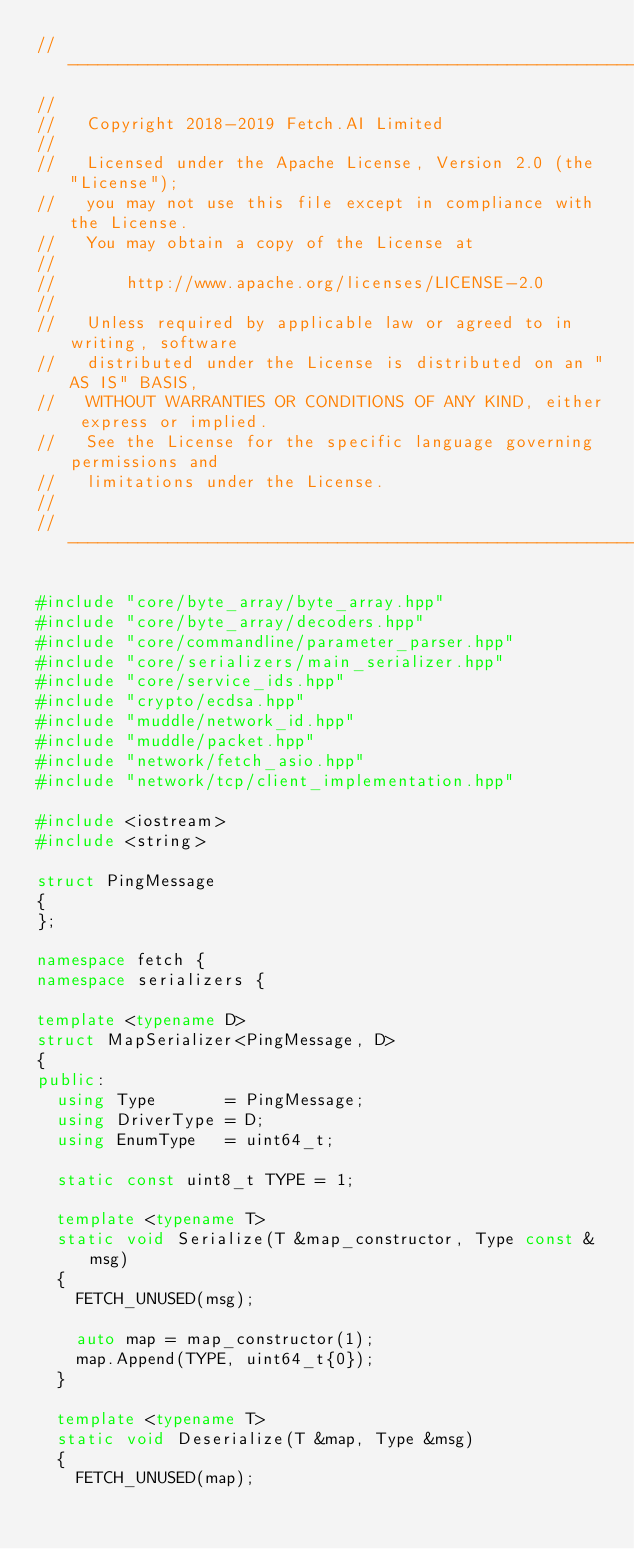Convert code to text. <code><loc_0><loc_0><loc_500><loc_500><_C++_>//------------------------------------------------------------------------------
//
//   Copyright 2018-2019 Fetch.AI Limited
//
//   Licensed under the Apache License, Version 2.0 (the "License");
//   you may not use this file except in compliance with the License.
//   You may obtain a copy of the License at
//
//       http://www.apache.org/licenses/LICENSE-2.0
//
//   Unless required by applicable law or agreed to in writing, software
//   distributed under the License is distributed on an "AS IS" BASIS,
//   WITHOUT WARRANTIES OR CONDITIONS OF ANY KIND, either express or implied.
//   See the License for the specific language governing permissions and
//   limitations under the License.
//
//------------------------------------------------------------------------------

#include "core/byte_array/byte_array.hpp"
#include "core/byte_array/decoders.hpp"
#include "core/commandline/parameter_parser.hpp"
#include "core/serializers/main_serializer.hpp"
#include "core/service_ids.hpp"
#include "crypto/ecdsa.hpp"
#include "muddle/network_id.hpp"
#include "muddle/packet.hpp"
#include "network/fetch_asio.hpp"
#include "network/tcp/client_implementation.hpp"

#include <iostream>
#include <string>

struct PingMessage
{
};

namespace fetch {
namespace serializers {

template <typename D>
struct MapSerializer<PingMessage, D>
{
public:
  using Type       = PingMessage;
  using DriverType = D;
  using EnumType   = uint64_t;

  static const uint8_t TYPE = 1;

  template <typename T>
  static void Serialize(T &map_constructor, Type const &msg)
  {
    FETCH_UNUSED(msg);

    auto map = map_constructor(1);
    map.Append(TYPE, uint64_t{0});
  }

  template <typename T>
  static void Deserialize(T &map, Type &msg)
  {
    FETCH_UNUSED(map);</code> 